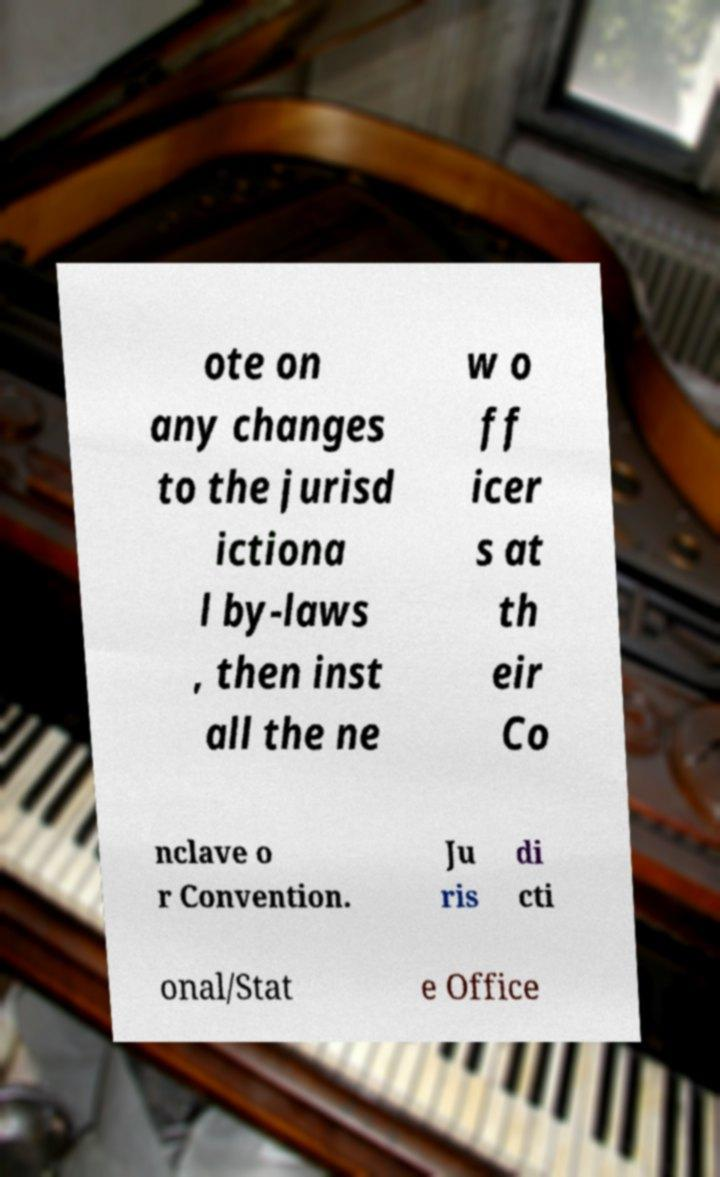Could you assist in decoding the text presented in this image and type it out clearly? ote on any changes to the jurisd ictiona l by-laws , then inst all the ne w o ff icer s at th eir Co nclave o r Convention. Ju ris di cti onal/Stat e Office 